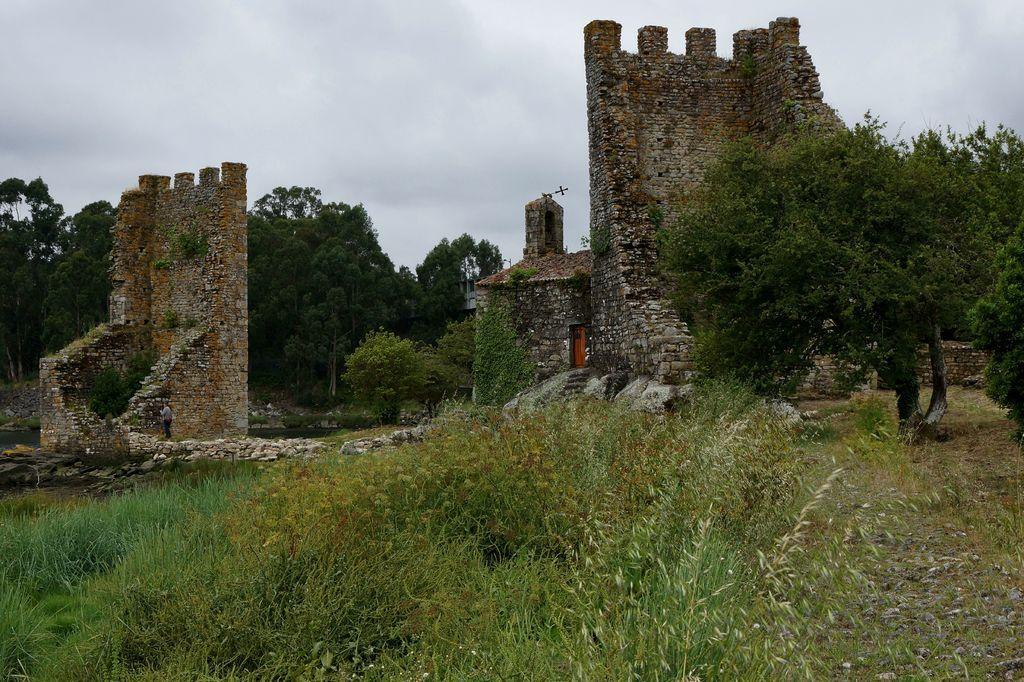How would you summarize this image in a sentence or two? There is a collapsed fort and there is a lot of trees and grass around the fort and there is a person standing in the left side in front of the fort wall. 